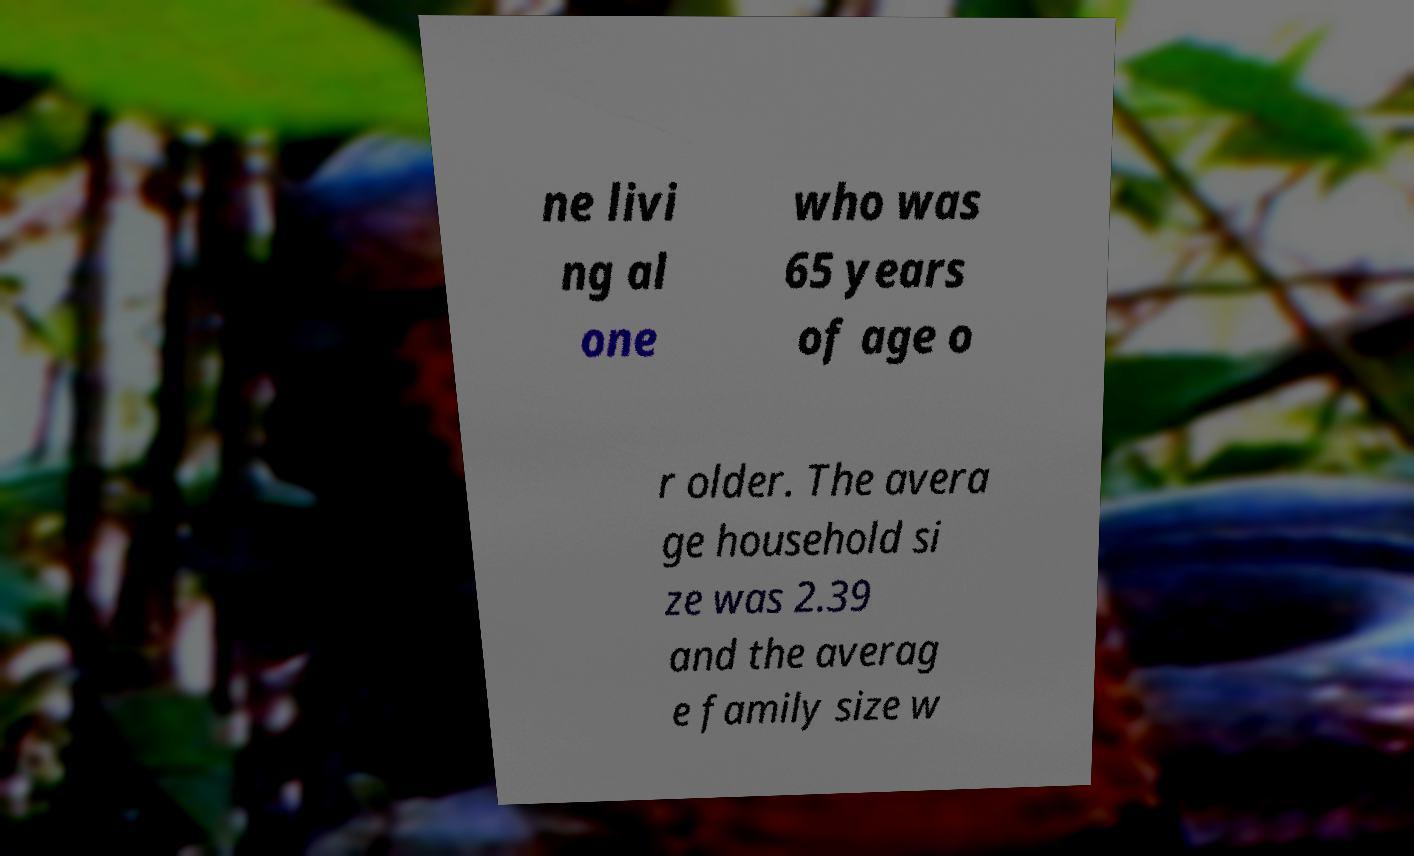I need the written content from this picture converted into text. Can you do that? ne livi ng al one who was 65 years of age o r older. The avera ge household si ze was 2.39 and the averag e family size w 